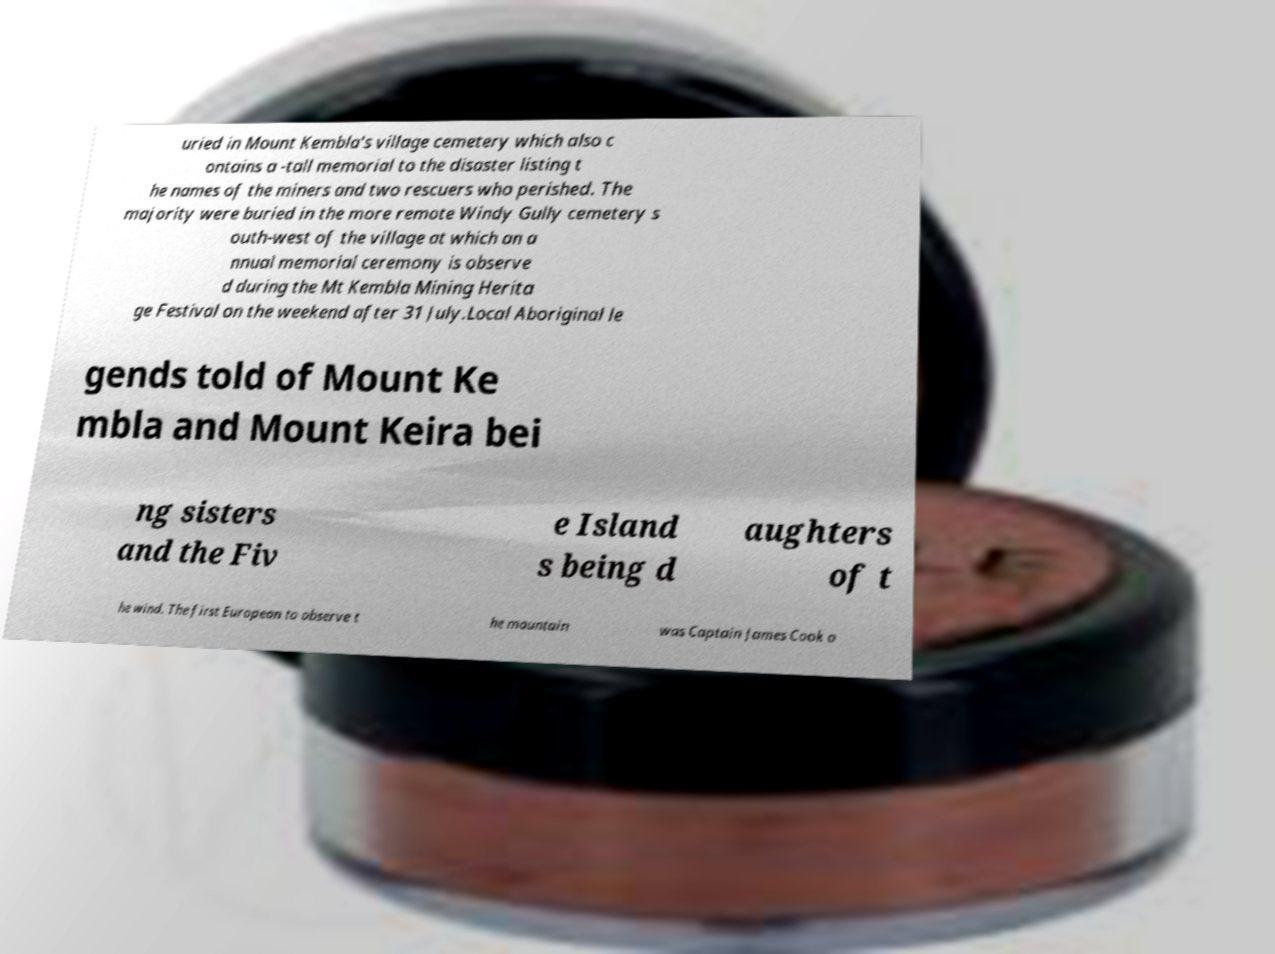Could you assist in decoding the text presented in this image and type it out clearly? uried in Mount Kembla's village cemetery which also c ontains a -tall memorial to the disaster listing t he names of the miners and two rescuers who perished. The majority were buried in the more remote Windy Gully cemetery s outh-west of the village at which an a nnual memorial ceremony is observe d during the Mt Kembla Mining Herita ge Festival on the weekend after 31 July.Local Aboriginal le gends told of Mount Ke mbla and Mount Keira bei ng sisters and the Fiv e Island s being d aughters of t he wind. The first European to observe t he mountain was Captain James Cook o 